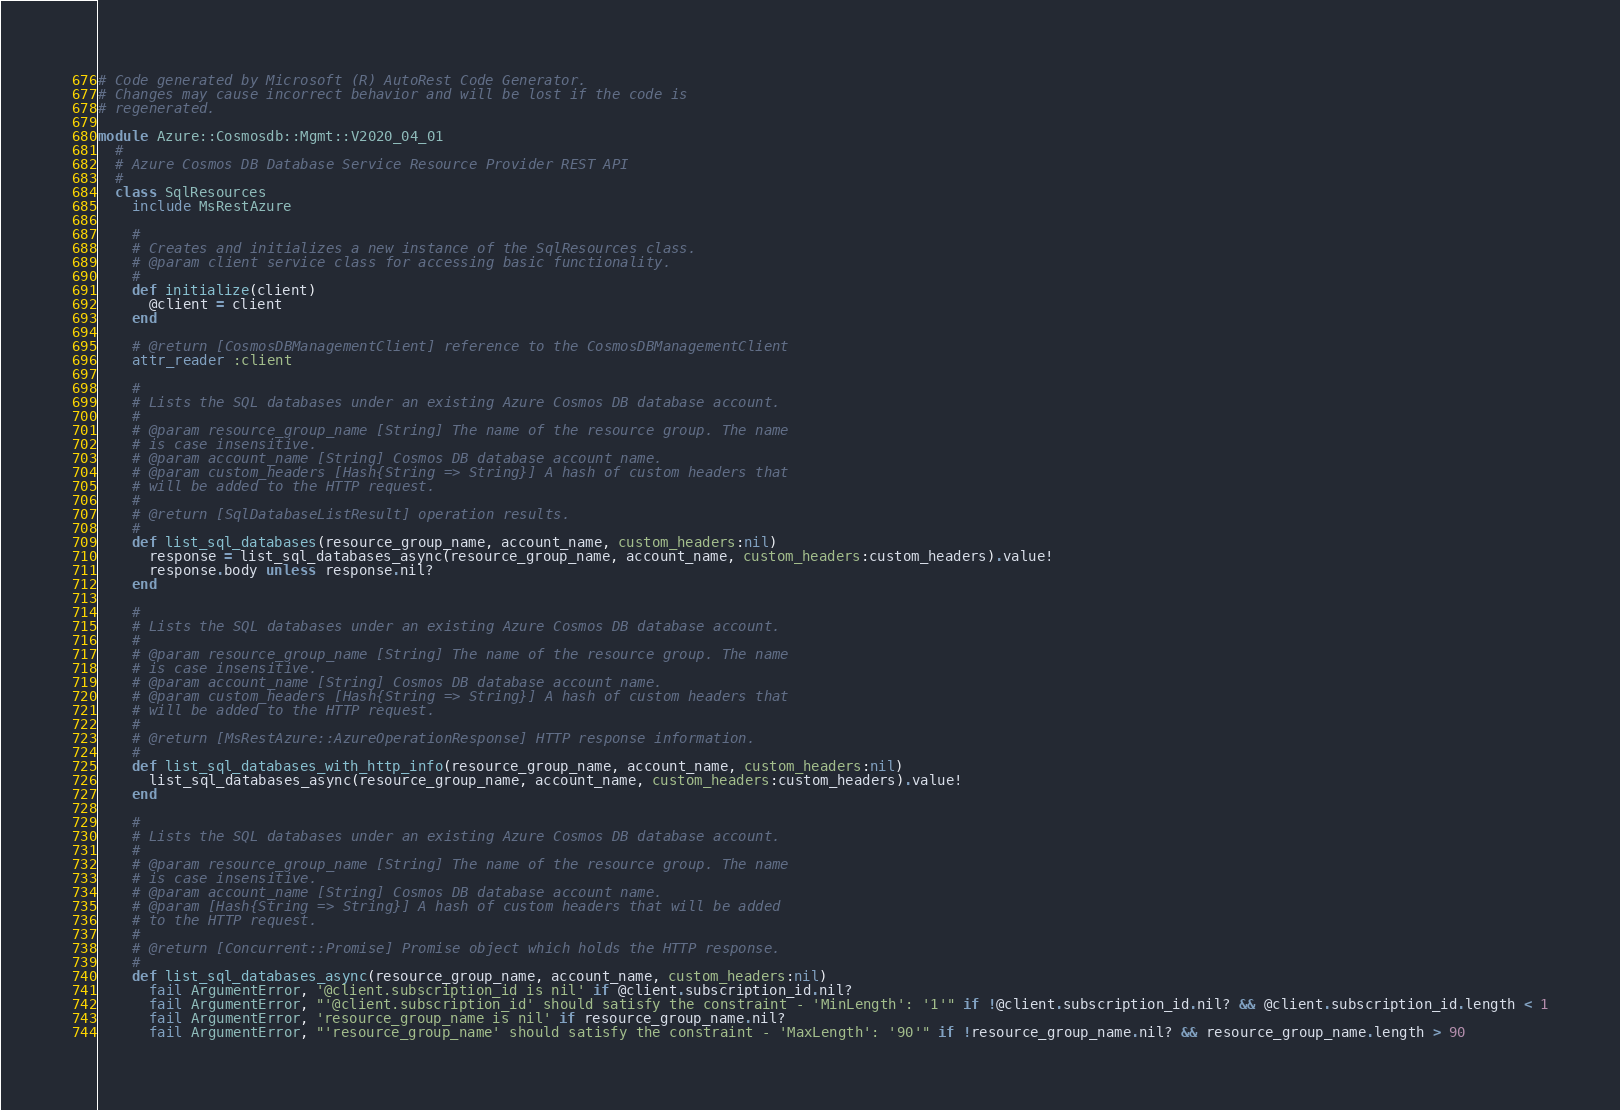<code> <loc_0><loc_0><loc_500><loc_500><_Ruby_># Code generated by Microsoft (R) AutoRest Code Generator.
# Changes may cause incorrect behavior and will be lost if the code is
# regenerated.

module Azure::Cosmosdb::Mgmt::V2020_04_01
  #
  # Azure Cosmos DB Database Service Resource Provider REST API
  #
  class SqlResources
    include MsRestAzure

    #
    # Creates and initializes a new instance of the SqlResources class.
    # @param client service class for accessing basic functionality.
    #
    def initialize(client)
      @client = client
    end

    # @return [CosmosDBManagementClient] reference to the CosmosDBManagementClient
    attr_reader :client

    #
    # Lists the SQL databases under an existing Azure Cosmos DB database account.
    #
    # @param resource_group_name [String] The name of the resource group. The name
    # is case insensitive.
    # @param account_name [String] Cosmos DB database account name.
    # @param custom_headers [Hash{String => String}] A hash of custom headers that
    # will be added to the HTTP request.
    #
    # @return [SqlDatabaseListResult] operation results.
    #
    def list_sql_databases(resource_group_name, account_name, custom_headers:nil)
      response = list_sql_databases_async(resource_group_name, account_name, custom_headers:custom_headers).value!
      response.body unless response.nil?
    end

    #
    # Lists the SQL databases under an existing Azure Cosmos DB database account.
    #
    # @param resource_group_name [String] The name of the resource group. The name
    # is case insensitive.
    # @param account_name [String] Cosmos DB database account name.
    # @param custom_headers [Hash{String => String}] A hash of custom headers that
    # will be added to the HTTP request.
    #
    # @return [MsRestAzure::AzureOperationResponse] HTTP response information.
    #
    def list_sql_databases_with_http_info(resource_group_name, account_name, custom_headers:nil)
      list_sql_databases_async(resource_group_name, account_name, custom_headers:custom_headers).value!
    end

    #
    # Lists the SQL databases under an existing Azure Cosmos DB database account.
    #
    # @param resource_group_name [String] The name of the resource group. The name
    # is case insensitive.
    # @param account_name [String] Cosmos DB database account name.
    # @param [Hash{String => String}] A hash of custom headers that will be added
    # to the HTTP request.
    #
    # @return [Concurrent::Promise] Promise object which holds the HTTP response.
    #
    def list_sql_databases_async(resource_group_name, account_name, custom_headers:nil)
      fail ArgumentError, '@client.subscription_id is nil' if @client.subscription_id.nil?
      fail ArgumentError, "'@client.subscription_id' should satisfy the constraint - 'MinLength': '1'" if !@client.subscription_id.nil? && @client.subscription_id.length < 1
      fail ArgumentError, 'resource_group_name is nil' if resource_group_name.nil?
      fail ArgumentError, "'resource_group_name' should satisfy the constraint - 'MaxLength': '90'" if !resource_group_name.nil? && resource_group_name.length > 90</code> 